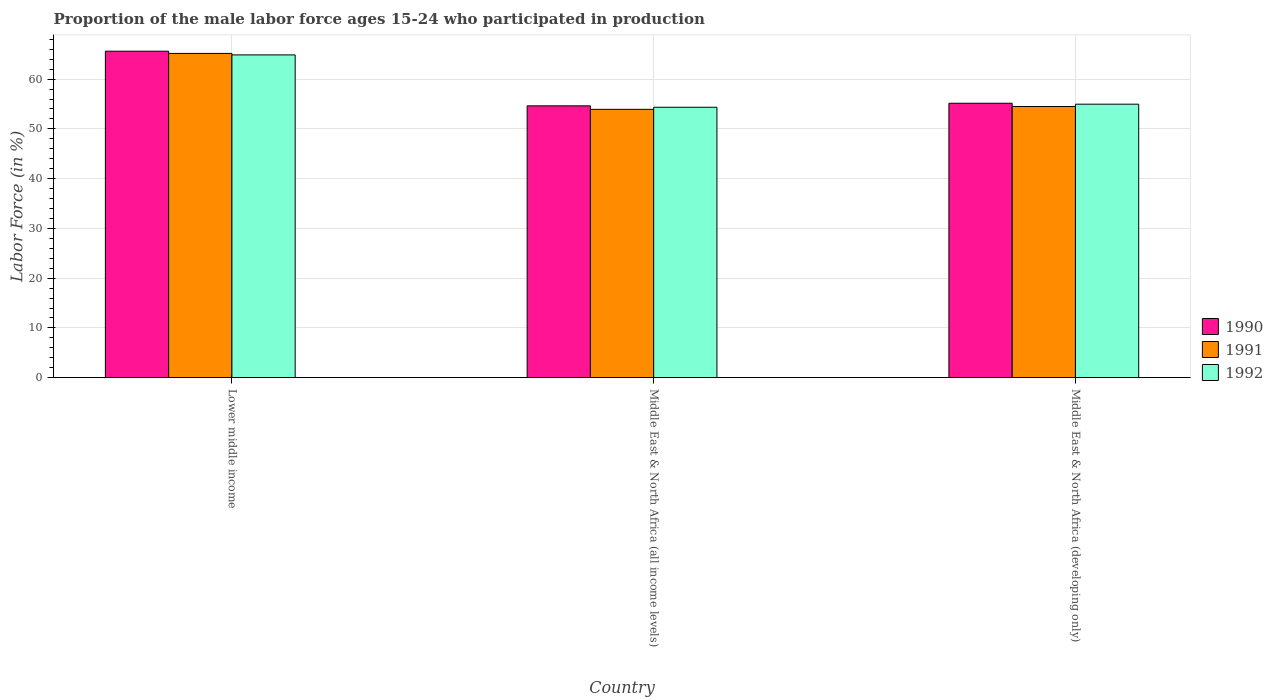Are the number of bars per tick equal to the number of legend labels?
Provide a short and direct response. Yes. Are the number of bars on each tick of the X-axis equal?
Your response must be concise. Yes. How many bars are there on the 1st tick from the left?
Provide a short and direct response. 3. How many bars are there on the 2nd tick from the right?
Provide a short and direct response. 3. What is the label of the 3rd group of bars from the left?
Provide a short and direct response. Middle East & North Africa (developing only). What is the proportion of the male labor force who participated in production in 1990 in Middle East & North Africa (developing only)?
Provide a succinct answer. 55.15. Across all countries, what is the maximum proportion of the male labor force who participated in production in 1991?
Keep it short and to the point. 65.17. Across all countries, what is the minimum proportion of the male labor force who participated in production in 1991?
Your answer should be compact. 53.93. In which country was the proportion of the male labor force who participated in production in 1991 maximum?
Provide a succinct answer. Lower middle income. In which country was the proportion of the male labor force who participated in production in 1992 minimum?
Provide a short and direct response. Middle East & North Africa (all income levels). What is the total proportion of the male labor force who participated in production in 1991 in the graph?
Keep it short and to the point. 173.61. What is the difference between the proportion of the male labor force who participated in production in 1992 in Middle East & North Africa (all income levels) and that in Middle East & North Africa (developing only)?
Provide a short and direct response. -0.62. What is the difference between the proportion of the male labor force who participated in production in 1991 in Middle East & North Africa (developing only) and the proportion of the male labor force who participated in production in 1992 in Middle East & North Africa (all income levels)?
Offer a terse response. 0.16. What is the average proportion of the male labor force who participated in production in 1990 per country?
Provide a succinct answer. 58.47. What is the difference between the proportion of the male labor force who participated in production of/in 1990 and proportion of the male labor force who participated in production of/in 1992 in Lower middle income?
Make the answer very short. 0.74. What is the ratio of the proportion of the male labor force who participated in production in 1990 in Lower middle income to that in Middle East & North Africa (developing only)?
Provide a short and direct response. 1.19. Is the difference between the proportion of the male labor force who participated in production in 1990 in Lower middle income and Middle East & North Africa (all income levels) greater than the difference between the proportion of the male labor force who participated in production in 1992 in Lower middle income and Middle East & North Africa (all income levels)?
Your answer should be very brief. Yes. What is the difference between the highest and the second highest proportion of the male labor force who participated in production in 1991?
Your response must be concise. 11.24. What is the difference between the highest and the lowest proportion of the male labor force who participated in production in 1991?
Your answer should be compact. 11.24. What does the 3rd bar from the right in Middle East & North Africa (all income levels) represents?
Provide a succinct answer. 1990. Is it the case that in every country, the sum of the proportion of the male labor force who participated in production in 1990 and proportion of the male labor force who participated in production in 1991 is greater than the proportion of the male labor force who participated in production in 1992?
Give a very brief answer. Yes. Are all the bars in the graph horizontal?
Provide a short and direct response. No. How many countries are there in the graph?
Your answer should be very brief. 3. What is the difference between two consecutive major ticks on the Y-axis?
Offer a terse response. 10. Does the graph contain grids?
Make the answer very short. Yes. How many legend labels are there?
Keep it short and to the point. 3. How are the legend labels stacked?
Make the answer very short. Vertical. What is the title of the graph?
Ensure brevity in your answer.  Proportion of the male labor force ages 15-24 who participated in production. Does "1961" appear as one of the legend labels in the graph?
Provide a succinct answer. No. What is the Labor Force (in %) of 1990 in Lower middle income?
Offer a terse response. 65.62. What is the Labor Force (in %) of 1991 in Lower middle income?
Your answer should be compact. 65.17. What is the Labor Force (in %) in 1992 in Lower middle income?
Your response must be concise. 64.87. What is the Labor Force (in %) in 1990 in Middle East & North Africa (all income levels)?
Give a very brief answer. 54.63. What is the Labor Force (in %) in 1991 in Middle East & North Africa (all income levels)?
Your response must be concise. 53.93. What is the Labor Force (in %) of 1992 in Middle East & North Africa (all income levels)?
Keep it short and to the point. 54.35. What is the Labor Force (in %) of 1990 in Middle East & North Africa (developing only)?
Offer a very short reply. 55.15. What is the Labor Force (in %) of 1991 in Middle East & North Africa (developing only)?
Make the answer very short. 54.5. What is the Labor Force (in %) in 1992 in Middle East & North Africa (developing only)?
Ensure brevity in your answer.  54.97. Across all countries, what is the maximum Labor Force (in %) of 1990?
Offer a very short reply. 65.62. Across all countries, what is the maximum Labor Force (in %) in 1991?
Your response must be concise. 65.17. Across all countries, what is the maximum Labor Force (in %) of 1992?
Make the answer very short. 64.87. Across all countries, what is the minimum Labor Force (in %) of 1990?
Your answer should be very brief. 54.63. Across all countries, what is the minimum Labor Force (in %) in 1991?
Provide a short and direct response. 53.93. Across all countries, what is the minimum Labor Force (in %) of 1992?
Give a very brief answer. 54.35. What is the total Labor Force (in %) of 1990 in the graph?
Provide a short and direct response. 175.4. What is the total Labor Force (in %) of 1991 in the graph?
Your response must be concise. 173.61. What is the total Labor Force (in %) of 1992 in the graph?
Make the answer very short. 174.19. What is the difference between the Labor Force (in %) in 1990 in Lower middle income and that in Middle East & North Africa (all income levels)?
Give a very brief answer. 10.99. What is the difference between the Labor Force (in %) in 1991 in Lower middle income and that in Middle East & North Africa (all income levels)?
Keep it short and to the point. 11.24. What is the difference between the Labor Force (in %) in 1992 in Lower middle income and that in Middle East & North Africa (all income levels)?
Your answer should be compact. 10.53. What is the difference between the Labor Force (in %) of 1990 in Lower middle income and that in Middle East & North Africa (developing only)?
Your answer should be very brief. 10.46. What is the difference between the Labor Force (in %) of 1991 in Lower middle income and that in Middle East & North Africa (developing only)?
Give a very brief answer. 10.67. What is the difference between the Labor Force (in %) in 1992 in Lower middle income and that in Middle East & North Africa (developing only)?
Give a very brief answer. 9.91. What is the difference between the Labor Force (in %) in 1990 in Middle East & North Africa (all income levels) and that in Middle East & North Africa (developing only)?
Your answer should be very brief. -0.52. What is the difference between the Labor Force (in %) in 1991 in Middle East & North Africa (all income levels) and that in Middle East & North Africa (developing only)?
Make the answer very short. -0.57. What is the difference between the Labor Force (in %) of 1992 in Middle East & North Africa (all income levels) and that in Middle East & North Africa (developing only)?
Offer a very short reply. -0.62. What is the difference between the Labor Force (in %) of 1990 in Lower middle income and the Labor Force (in %) of 1991 in Middle East & North Africa (all income levels)?
Your answer should be compact. 11.68. What is the difference between the Labor Force (in %) in 1990 in Lower middle income and the Labor Force (in %) in 1992 in Middle East & North Africa (all income levels)?
Give a very brief answer. 11.27. What is the difference between the Labor Force (in %) in 1991 in Lower middle income and the Labor Force (in %) in 1992 in Middle East & North Africa (all income levels)?
Give a very brief answer. 10.82. What is the difference between the Labor Force (in %) in 1990 in Lower middle income and the Labor Force (in %) in 1991 in Middle East & North Africa (developing only)?
Your answer should be very brief. 11.11. What is the difference between the Labor Force (in %) of 1990 in Lower middle income and the Labor Force (in %) of 1992 in Middle East & North Africa (developing only)?
Offer a terse response. 10.65. What is the difference between the Labor Force (in %) of 1991 in Lower middle income and the Labor Force (in %) of 1992 in Middle East & North Africa (developing only)?
Provide a short and direct response. 10.2. What is the difference between the Labor Force (in %) of 1990 in Middle East & North Africa (all income levels) and the Labor Force (in %) of 1991 in Middle East & North Africa (developing only)?
Provide a short and direct response. 0.13. What is the difference between the Labor Force (in %) of 1990 in Middle East & North Africa (all income levels) and the Labor Force (in %) of 1992 in Middle East & North Africa (developing only)?
Keep it short and to the point. -0.34. What is the difference between the Labor Force (in %) in 1991 in Middle East & North Africa (all income levels) and the Labor Force (in %) in 1992 in Middle East & North Africa (developing only)?
Keep it short and to the point. -1.04. What is the average Labor Force (in %) in 1990 per country?
Provide a short and direct response. 58.47. What is the average Labor Force (in %) in 1991 per country?
Provide a short and direct response. 57.87. What is the average Labor Force (in %) in 1992 per country?
Your response must be concise. 58.06. What is the difference between the Labor Force (in %) in 1990 and Labor Force (in %) in 1991 in Lower middle income?
Your response must be concise. 0.45. What is the difference between the Labor Force (in %) in 1990 and Labor Force (in %) in 1992 in Lower middle income?
Keep it short and to the point. 0.74. What is the difference between the Labor Force (in %) in 1991 and Labor Force (in %) in 1992 in Lower middle income?
Ensure brevity in your answer.  0.3. What is the difference between the Labor Force (in %) of 1990 and Labor Force (in %) of 1991 in Middle East & North Africa (all income levels)?
Make the answer very short. 0.7. What is the difference between the Labor Force (in %) in 1990 and Labor Force (in %) in 1992 in Middle East & North Africa (all income levels)?
Your response must be concise. 0.28. What is the difference between the Labor Force (in %) in 1991 and Labor Force (in %) in 1992 in Middle East & North Africa (all income levels)?
Offer a very short reply. -0.42. What is the difference between the Labor Force (in %) in 1990 and Labor Force (in %) in 1991 in Middle East & North Africa (developing only)?
Your answer should be very brief. 0.65. What is the difference between the Labor Force (in %) of 1990 and Labor Force (in %) of 1992 in Middle East & North Africa (developing only)?
Keep it short and to the point. 0.18. What is the difference between the Labor Force (in %) of 1991 and Labor Force (in %) of 1992 in Middle East & North Africa (developing only)?
Offer a terse response. -0.47. What is the ratio of the Labor Force (in %) in 1990 in Lower middle income to that in Middle East & North Africa (all income levels)?
Your response must be concise. 1.2. What is the ratio of the Labor Force (in %) in 1991 in Lower middle income to that in Middle East & North Africa (all income levels)?
Your answer should be compact. 1.21. What is the ratio of the Labor Force (in %) in 1992 in Lower middle income to that in Middle East & North Africa (all income levels)?
Keep it short and to the point. 1.19. What is the ratio of the Labor Force (in %) in 1990 in Lower middle income to that in Middle East & North Africa (developing only)?
Offer a terse response. 1.19. What is the ratio of the Labor Force (in %) in 1991 in Lower middle income to that in Middle East & North Africa (developing only)?
Provide a succinct answer. 1.2. What is the ratio of the Labor Force (in %) of 1992 in Lower middle income to that in Middle East & North Africa (developing only)?
Provide a succinct answer. 1.18. What is the ratio of the Labor Force (in %) in 1990 in Middle East & North Africa (all income levels) to that in Middle East & North Africa (developing only)?
Offer a very short reply. 0.99. What is the ratio of the Labor Force (in %) of 1992 in Middle East & North Africa (all income levels) to that in Middle East & North Africa (developing only)?
Your answer should be very brief. 0.99. What is the difference between the highest and the second highest Labor Force (in %) in 1990?
Provide a short and direct response. 10.46. What is the difference between the highest and the second highest Labor Force (in %) of 1991?
Make the answer very short. 10.67. What is the difference between the highest and the second highest Labor Force (in %) in 1992?
Your answer should be compact. 9.91. What is the difference between the highest and the lowest Labor Force (in %) of 1990?
Provide a short and direct response. 10.99. What is the difference between the highest and the lowest Labor Force (in %) of 1991?
Your answer should be compact. 11.24. What is the difference between the highest and the lowest Labor Force (in %) in 1992?
Provide a succinct answer. 10.53. 